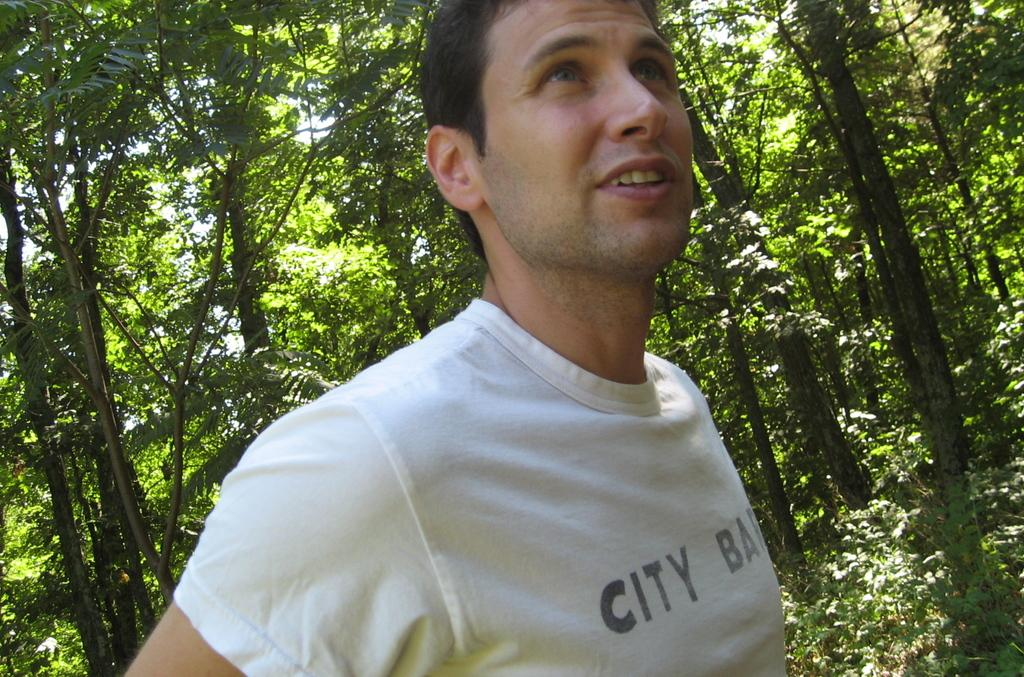Who is present in the image? There is a man in the image. What is the man doing in the image? The man is standing. What is the man wearing in the image? The man is wearing a white t-shirt. What can be seen in the background of the image? There are trees visible in the background of the image. What time of day is it in the image, based on the hour? The provided facts do not mention the time of day or any specific hour, so it cannot be determined from the image. 